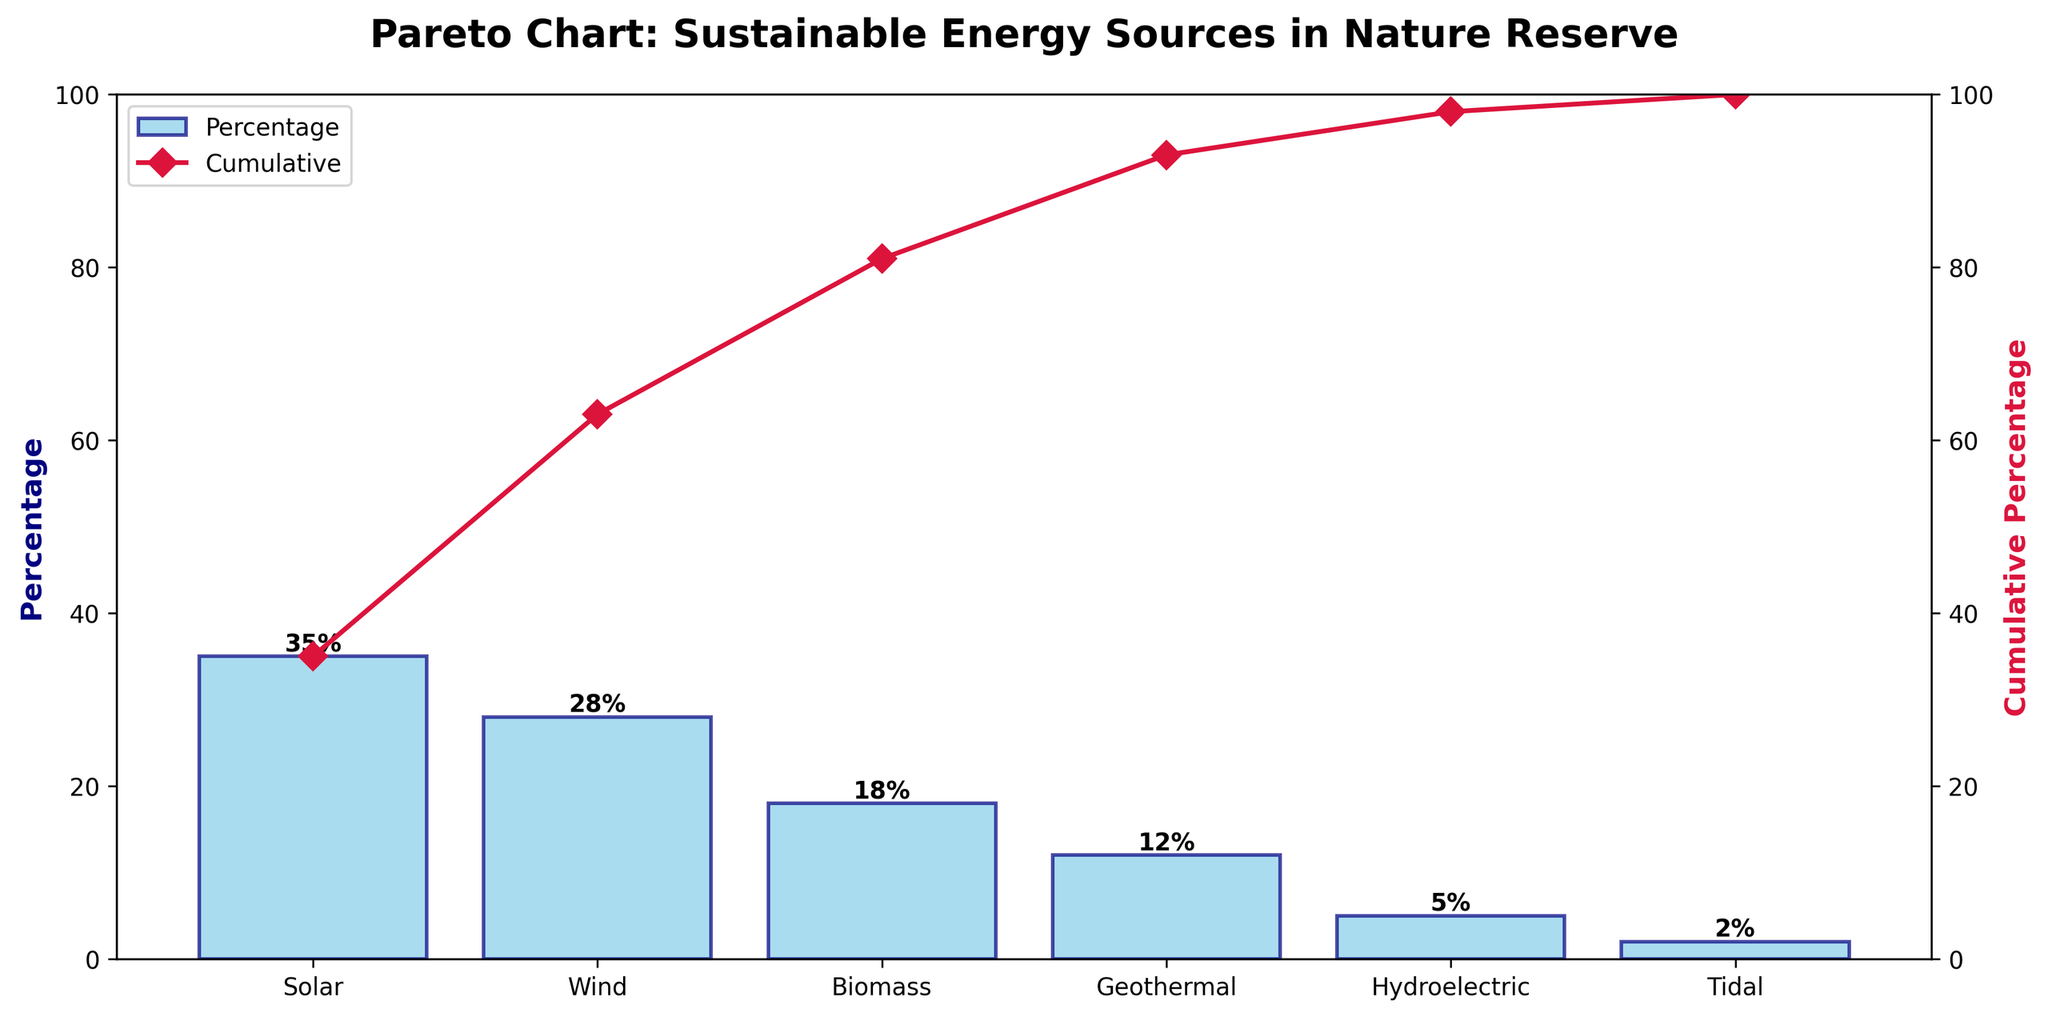`What is the title of the chart?` The title of the chart is usually displayed at the top of the figure. In this case, it reads "Pareto Chart: Sustainable Energy Sources in Nature Reserve" based on the provided code.
Answer: Pareto Chart: Sustainable Energy Sources in Nature Reserve `Which energy source has the highest percentage of total energy consumption?` By observing the height of the bars, we can see that the "Solar" bar is the tallest, and its label indicates 35%.
Answer: Solar `How many energy sources are represented in the chart?` By counting the number of bars on the x-axis, we can see there are six energy sources.
Answer: Six `What is the cumulative percentage for Wind energy?` By looking at the corresponding point on the cumulative line for Wind, we see it intersects at 63% (Solar 35% + Wind 28%).
Answer: 63% `Is Biomass energy's percentage higher or lower than Geothermal energy's percentage?` By comparing the heights of the Biomass (18%) and Geothermal (12%) bars, we see that Biomass is higher.
Answer: Higher `What is the cumulative percentage up to Biomass energy?` Adding the percentages step by step: Solar (35%) + Wind (28%) + Biomass (18%) = 81%.
Answer: 81% `Which energy sources contribute to more than half of the total energy consumption?` Observing the cumulative line, we see that Solar and Wind combined exceed 50% (Solar 35% + Wind 28% = 63%).
Answer: Solar and Wind `What percentage of total energy consumption does Tidal energy make up?` By reading the label on the Tidal bar, it shows 2%.
Answer: 2% `What energy source has the smallest contribution to the total energy consumption?` The shortest bar in the chart is Tidal, corresponding to 2%.
Answer: Tidal 